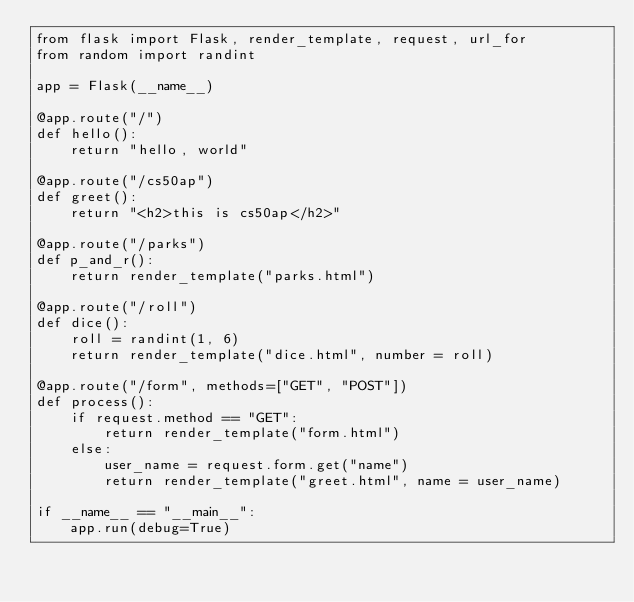Convert code to text. <code><loc_0><loc_0><loc_500><loc_500><_Python_>from flask import Flask, render_template, request, url_for
from random import randint

app = Flask(__name__)

@app.route("/")
def hello():
    return "hello, world"

@app.route("/cs50ap")
def greet():
    return "<h2>this is cs50ap</h2>"

@app.route("/parks")
def p_and_r():
    return render_template("parks.html")

@app.route("/roll")
def dice():
    roll = randint(1, 6)
    return render_template("dice.html", number = roll)

@app.route("/form", methods=["GET", "POST"])
def process():
    if request.method == "GET":
        return render_template("form.html")
    else:
        user_name = request.form.get("name")
        return render_template("greet.html", name = user_name)

if __name__ == "__main__":
    app.run(debug=True)</code> 